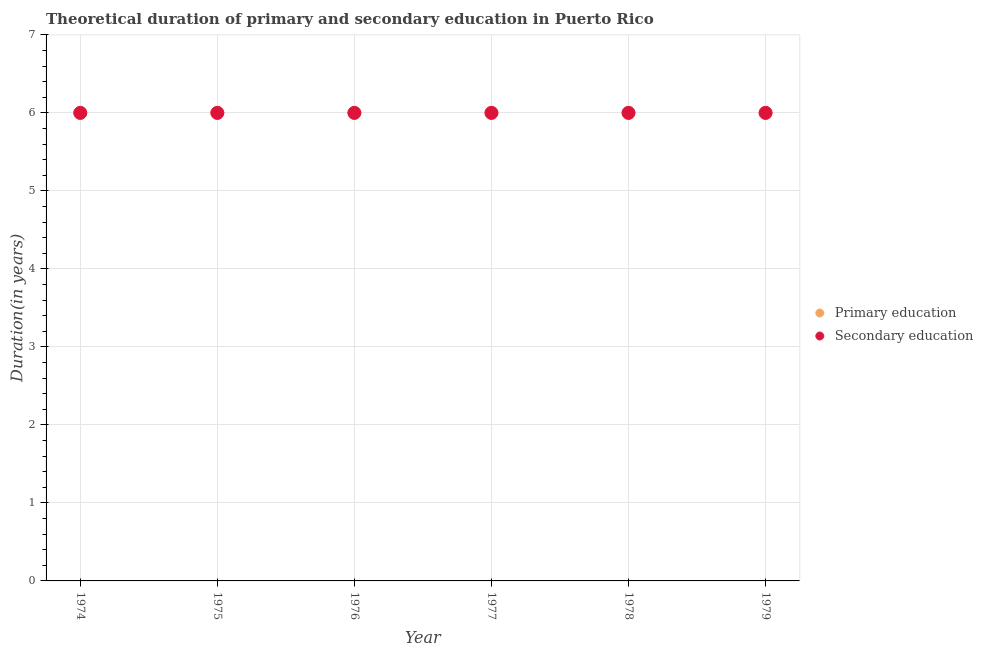How many different coloured dotlines are there?
Offer a terse response. 2. Is the number of dotlines equal to the number of legend labels?
Your answer should be very brief. Yes. Across all years, what is the maximum duration of primary education?
Keep it short and to the point. 6. In which year was the duration of secondary education maximum?
Your response must be concise. 1974. In which year was the duration of secondary education minimum?
Give a very brief answer. 1974. What is the total duration of primary education in the graph?
Your answer should be compact. 36. What is the difference between the duration of secondary education in 1977 and that in 1978?
Offer a very short reply. 0. What is the difference between the duration of secondary education in 1975 and the duration of primary education in 1977?
Provide a short and direct response. 0. What is the average duration of primary education per year?
Ensure brevity in your answer.  6. In how many years, is the duration of primary education greater than 2.8 years?
Keep it short and to the point. 6. What is the ratio of the duration of primary education in 1977 to that in 1979?
Ensure brevity in your answer.  1. In how many years, is the duration of primary education greater than the average duration of primary education taken over all years?
Offer a very short reply. 0. Does the duration of secondary education monotonically increase over the years?
Ensure brevity in your answer.  No. What is the difference between two consecutive major ticks on the Y-axis?
Your response must be concise. 1. What is the title of the graph?
Your answer should be very brief. Theoretical duration of primary and secondary education in Puerto Rico. Does "Research and Development" appear as one of the legend labels in the graph?
Keep it short and to the point. No. What is the label or title of the X-axis?
Ensure brevity in your answer.  Year. What is the label or title of the Y-axis?
Make the answer very short. Duration(in years). What is the Duration(in years) of Primary education in 1974?
Your answer should be very brief. 6. What is the Duration(in years) in Secondary education in 1974?
Provide a short and direct response. 6. What is the Duration(in years) of Primary education in 1975?
Offer a terse response. 6. What is the Duration(in years) in Secondary education in 1975?
Provide a succinct answer. 6. What is the Duration(in years) of Primary education in 1976?
Offer a terse response. 6. What is the Duration(in years) of Secondary education in 1976?
Ensure brevity in your answer.  6. What is the Duration(in years) of Primary education in 1977?
Ensure brevity in your answer.  6. Across all years, what is the maximum Duration(in years) in Primary education?
Provide a succinct answer. 6. Across all years, what is the maximum Duration(in years) in Secondary education?
Provide a short and direct response. 6. Across all years, what is the minimum Duration(in years) of Primary education?
Offer a terse response. 6. What is the total Duration(in years) in Primary education in the graph?
Keep it short and to the point. 36. What is the total Duration(in years) in Secondary education in the graph?
Provide a short and direct response. 36. What is the difference between the Duration(in years) of Secondary education in 1974 and that in 1975?
Ensure brevity in your answer.  0. What is the difference between the Duration(in years) of Primary education in 1974 and that in 1977?
Offer a terse response. 0. What is the difference between the Duration(in years) in Secondary education in 1974 and that in 1977?
Your answer should be very brief. 0. What is the difference between the Duration(in years) in Primary education in 1974 and that in 1979?
Ensure brevity in your answer.  0. What is the difference between the Duration(in years) in Secondary education in 1974 and that in 1979?
Your response must be concise. 0. What is the difference between the Duration(in years) of Primary education in 1975 and that in 1976?
Your response must be concise. 0. What is the difference between the Duration(in years) in Secondary education in 1975 and that in 1976?
Your response must be concise. 0. What is the difference between the Duration(in years) of Secondary education in 1975 and that in 1977?
Offer a very short reply. 0. What is the difference between the Duration(in years) in Primary education in 1975 and that in 1978?
Provide a short and direct response. 0. What is the difference between the Duration(in years) of Primary education in 1976 and that in 1977?
Your answer should be very brief. 0. What is the difference between the Duration(in years) in Secondary education in 1976 and that in 1978?
Your answer should be very brief. 0. What is the difference between the Duration(in years) in Primary education in 1976 and that in 1979?
Your answer should be compact. 0. What is the difference between the Duration(in years) of Secondary education in 1977 and that in 1978?
Provide a short and direct response. 0. What is the difference between the Duration(in years) of Secondary education in 1977 and that in 1979?
Your answer should be very brief. 0. What is the difference between the Duration(in years) in Secondary education in 1978 and that in 1979?
Your answer should be compact. 0. What is the difference between the Duration(in years) of Primary education in 1974 and the Duration(in years) of Secondary education in 1976?
Provide a succinct answer. 0. What is the difference between the Duration(in years) of Primary education in 1974 and the Duration(in years) of Secondary education in 1977?
Provide a short and direct response. 0. What is the difference between the Duration(in years) in Primary education in 1974 and the Duration(in years) in Secondary education in 1978?
Provide a short and direct response. 0. What is the difference between the Duration(in years) in Primary education in 1975 and the Duration(in years) in Secondary education in 1977?
Your answer should be very brief. 0. What is the difference between the Duration(in years) in Primary education in 1976 and the Duration(in years) in Secondary education in 1977?
Make the answer very short. 0. What is the difference between the Duration(in years) in Primary education in 1976 and the Duration(in years) in Secondary education in 1978?
Your answer should be compact. 0. What is the difference between the Duration(in years) of Primary education in 1976 and the Duration(in years) of Secondary education in 1979?
Ensure brevity in your answer.  0. What is the difference between the Duration(in years) of Primary education in 1977 and the Duration(in years) of Secondary education in 1978?
Give a very brief answer. 0. What is the difference between the Duration(in years) of Primary education in 1977 and the Duration(in years) of Secondary education in 1979?
Offer a very short reply. 0. In the year 1975, what is the difference between the Duration(in years) in Primary education and Duration(in years) in Secondary education?
Your response must be concise. 0. In the year 1976, what is the difference between the Duration(in years) in Primary education and Duration(in years) in Secondary education?
Provide a short and direct response. 0. In the year 1979, what is the difference between the Duration(in years) in Primary education and Duration(in years) in Secondary education?
Provide a succinct answer. 0. What is the ratio of the Duration(in years) of Secondary education in 1974 to that in 1975?
Your response must be concise. 1. What is the ratio of the Duration(in years) of Primary education in 1974 to that in 1976?
Provide a short and direct response. 1. What is the ratio of the Duration(in years) of Secondary education in 1974 to that in 1976?
Provide a succinct answer. 1. What is the ratio of the Duration(in years) in Primary education in 1974 to that in 1977?
Provide a succinct answer. 1. What is the ratio of the Duration(in years) in Secondary education in 1974 to that in 1977?
Your response must be concise. 1. What is the ratio of the Duration(in years) in Secondary education in 1975 to that in 1977?
Your response must be concise. 1. What is the ratio of the Duration(in years) in Primary education in 1975 to that in 1978?
Provide a short and direct response. 1. What is the ratio of the Duration(in years) of Secondary education in 1975 to that in 1978?
Ensure brevity in your answer.  1. What is the ratio of the Duration(in years) in Primary education in 1975 to that in 1979?
Your answer should be very brief. 1. What is the ratio of the Duration(in years) in Secondary education in 1975 to that in 1979?
Your response must be concise. 1. What is the ratio of the Duration(in years) of Primary education in 1976 to that in 1977?
Your answer should be very brief. 1. What is the ratio of the Duration(in years) of Primary education in 1976 to that in 1978?
Keep it short and to the point. 1. What is the ratio of the Duration(in years) in Secondary education in 1976 to that in 1978?
Ensure brevity in your answer.  1. What is the ratio of the Duration(in years) of Secondary education in 1977 to that in 1978?
Your answer should be very brief. 1. What is the ratio of the Duration(in years) in Secondary education in 1977 to that in 1979?
Offer a terse response. 1. What is the difference between the highest and the second highest Duration(in years) in Primary education?
Give a very brief answer. 0. What is the difference between the highest and the lowest Duration(in years) in Primary education?
Your response must be concise. 0. 